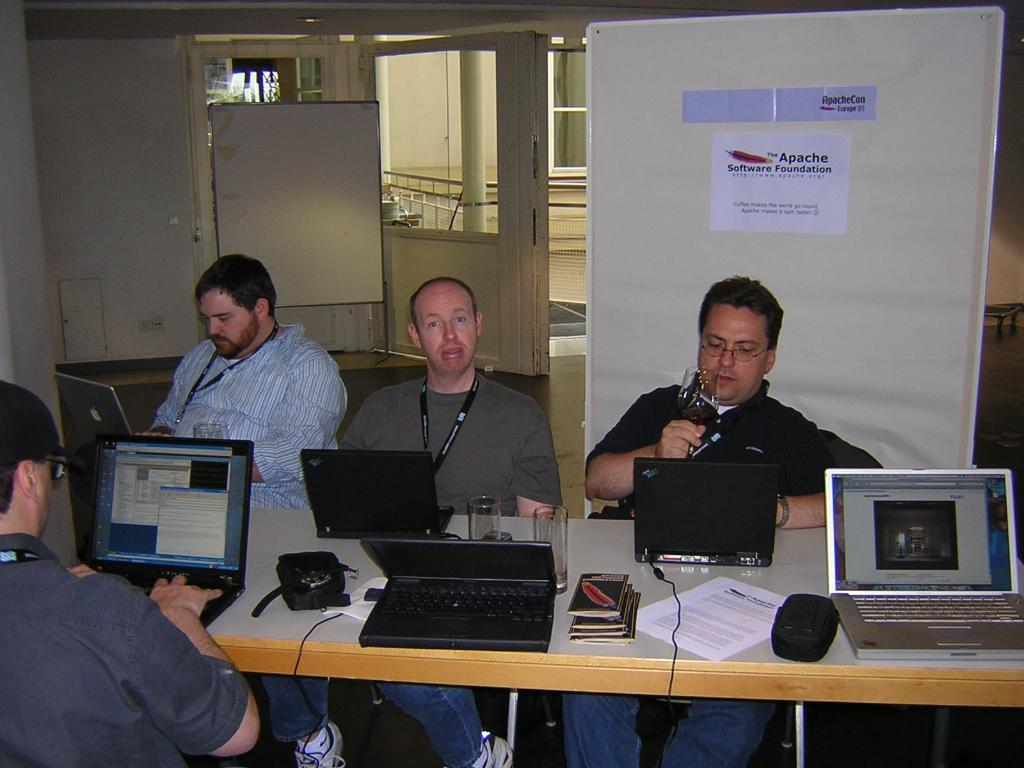What are the people in the image doing? The people in the image are sitting on chairs. What objects can be seen on the table in the image? There are laptops on a table in the image. What can be seen in the background of the image? There is a whiteboard in the background of the image. What type of music can be heard coming from the basin in the image? There is no basin present in the image, and therefore no music can be heard coming from it. 